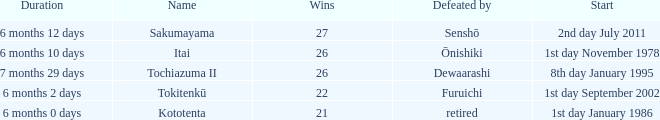Which Start has a Duration of 6 months 2 days? 1st day September 2002. 